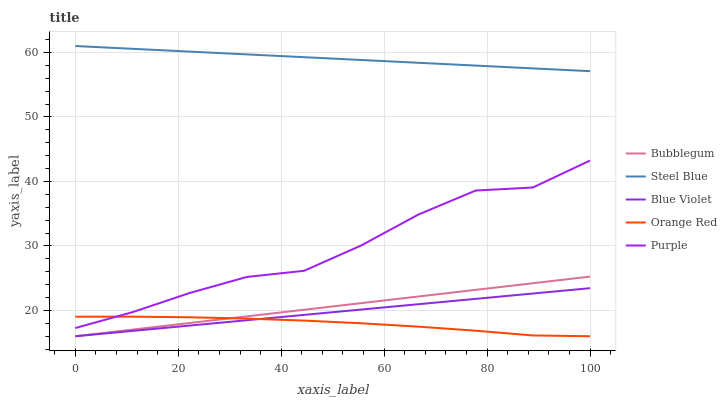Does Orange Red have the minimum area under the curve?
Answer yes or no. Yes. Does Steel Blue have the maximum area under the curve?
Answer yes or no. Yes. Does Purple have the minimum area under the curve?
Answer yes or no. No. Does Purple have the maximum area under the curve?
Answer yes or no. No. Is Blue Violet the smoothest?
Answer yes or no. Yes. Is Purple the roughest?
Answer yes or no. Yes. Is Steel Blue the smoothest?
Answer yes or no. No. Is Steel Blue the roughest?
Answer yes or no. No. Does Blue Violet have the lowest value?
Answer yes or no. Yes. Does Purple have the lowest value?
Answer yes or no. No. Does Steel Blue have the highest value?
Answer yes or no. Yes. Does Purple have the highest value?
Answer yes or no. No. Is Bubblegum less than Steel Blue?
Answer yes or no. Yes. Is Steel Blue greater than Bubblegum?
Answer yes or no. Yes. Does Blue Violet intersect Bubblegum?
Answer yes or no. Yes. Is Blue Violet less than Bubblegum?
Answer yes or no. No. Is Blue Violet greater than Bubblegum?
Answer yes or no. No. Does Bubblegum intersect Steel Blue?
Answer yes or no. No. 